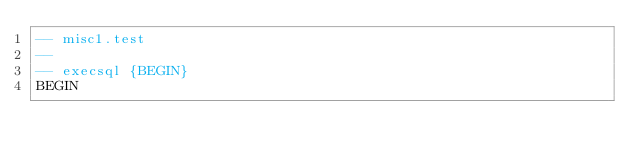Convert code to text. <code><loc_0><loc_0><loc_500><loc_500><_SQL_>-- misc1.test
-- 
-- execsql {BEGIN}
BEGIN</code> 